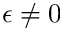<formula> <loc_0><loc_0><loc_500><loc_500>\epsilon \neq 0</formula> 